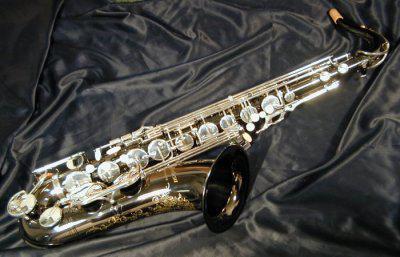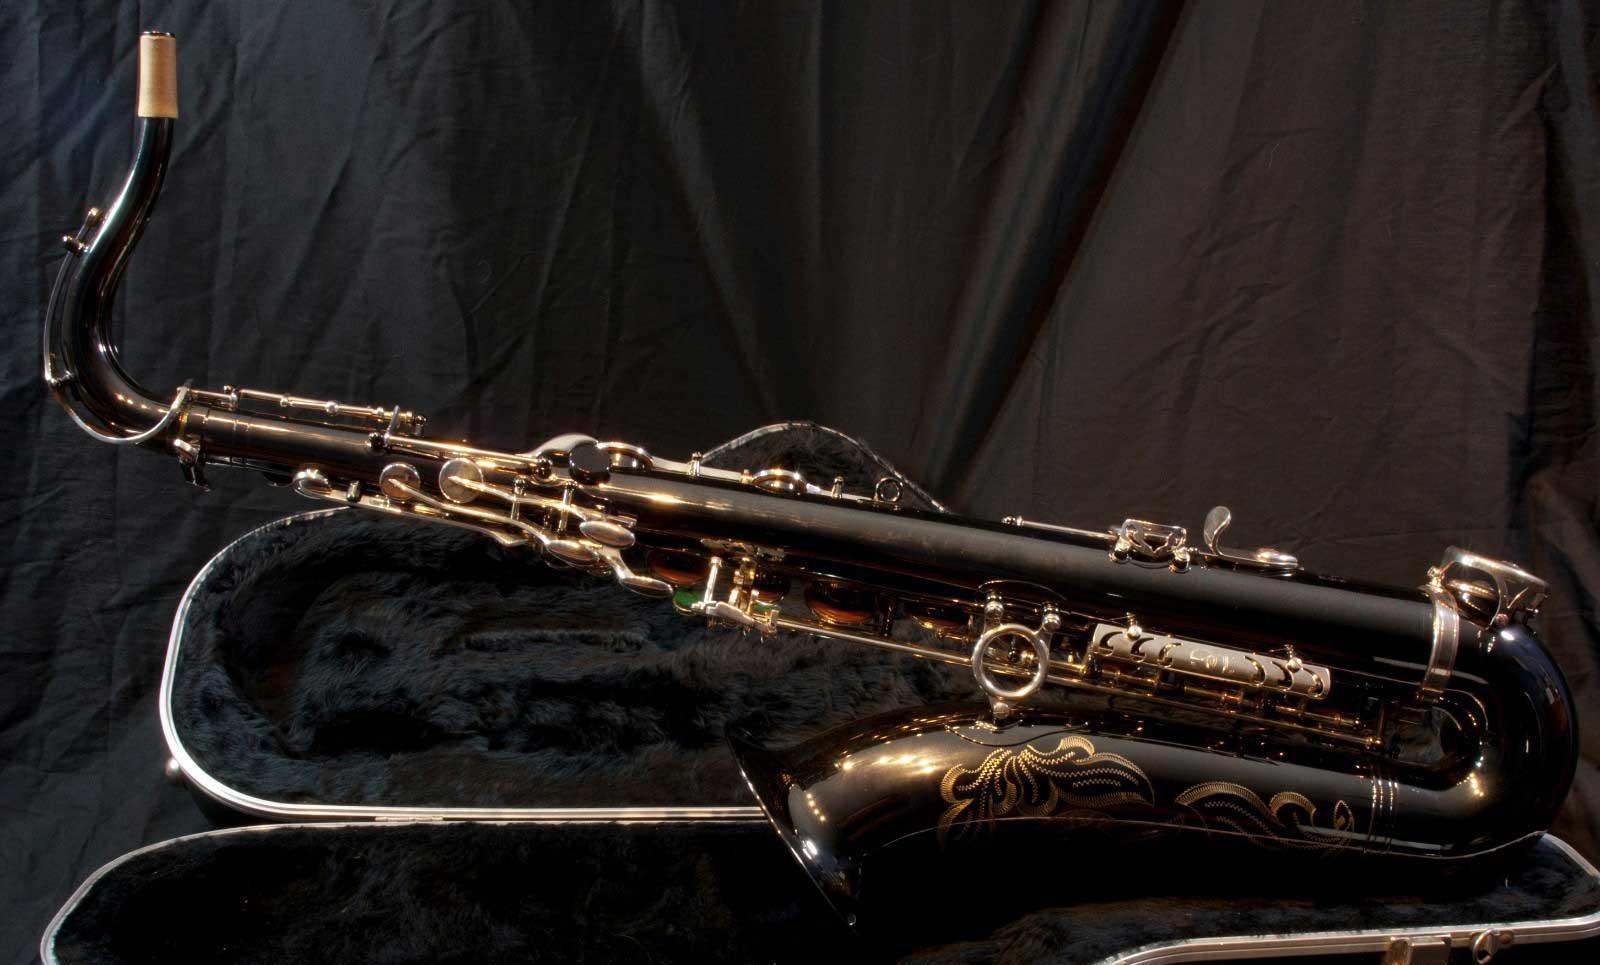The first image is the image on the left, the second image is the image on the right. For the images displayed, is the sentence "The saxophones are all sitting on black materials." factually correct? Answer yes or no. Yes. 